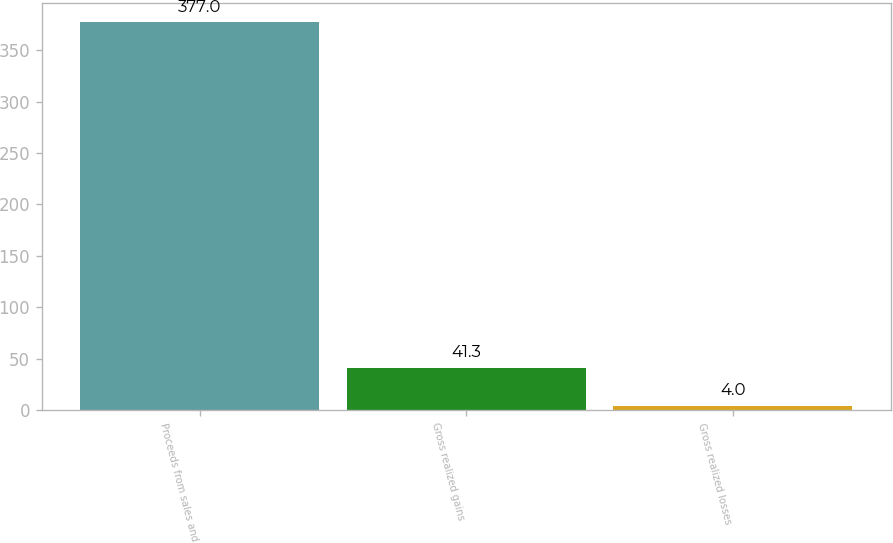<chart> <loc_0><loc_0><loc_500><loc_500><bar_chart><fcel>Proceeds from sales and<fcel>Gross realized gains<fcel>Gross realized losses<nl><fcel>377<fcel>41.3<fcel>4<nl></chart> 